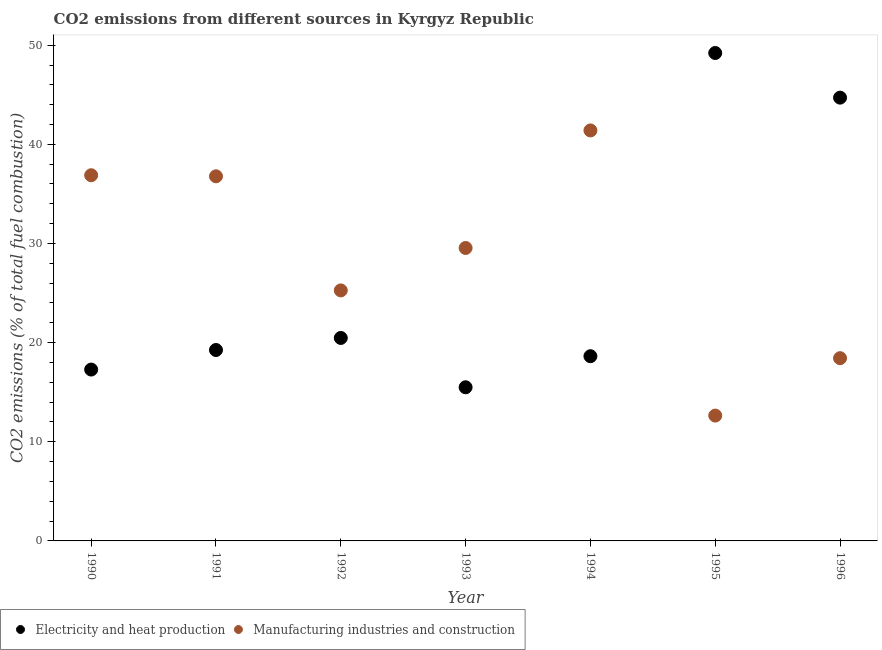Is the number of dotlines equal to the number of legend labels?
Give a very brief answer. Yes. What is the co2 emissions due to electricity and heat production in 1996?
Provide a short and direct response. 44.71. Across all years, what is the maximum co2 emissions due to electricity and heat production?
Make the answer very short. 49.21. Across all years, what is the minimum co2 emissions due to manufacturing industries?
Provide a short and direct response. 12.64. In which year was the co2 emissions due to manufacturing industries minimum?
Your answer should be compact. 1995. What is the total co2 emissions due to manufacturing industries in the graph?
Ensure brevity in your answer.  200.94. What is the difference between the co2 emissions due to electricity and heat production in 1992 and that in 1993?
Your answer should be very brief. 4.98. What is the difference between the co2 emissions due to manufacturing industries in 1994 and the co2 emissions due to electricity and heat production in 1993?
Ensure brevity in your answer.  25.91. What is the average co2 emissions due to electricity and heat production per year?
Your answer should be very brief. 26.44. In the year 1994, what is the difference between the co2 emissions due to electricity and heat production and co2 emissions due to manufacturing industries?
Your answer should be very brief. -22.77. What is the ratio of the co2 emissions due to manufacturing industries in 1992 to that in 1994?
Offer a very short reply. 0.61. Is the co2 emissions due to manufacturing industries in 1990 less than that in 1994?
Keep it short and to the point. Yes. What is the difference between the highest and the second highest co2 emissions due to manufacturing industries?
Provide a short and direct response. 4.52. What is the difference between the highest and the lowest co2 emissions due to electricity and heat production?
Your response must be concise. 33.71. Does the co2 emissions due to electricity and heat production monotonically increase over the years?
Offer a very short reply. No. Is the co2 emissions due to manufacturing industries strictly greater than the co2 emissions due to electricity and heat production over the years?
Your answer should be very brief. No. How many dotlines are there?
Provide a short and direct response. 2. What is the difference between two consecutive major ticks on the Y-axis?
Offer a terse response. 10. Are the values on the major ticks of Y-axis written in scientific E-notation?
Make the answer very short. No. Does the graph contain grids?
Offer a very short reply. No. How are the legend labels stacked?
Make the answer very short. Horizontal. What is the title of the graph?
Provide a short and direct response. CO2 emissions from different sources in Kyrgyz Republic. Does "Overweight" appear as one of the legend labels in the graph?
Make the answer very short. No. What is the label or title of the Y-axis?
Make the answer very short. CO2 emissions (% of total fuel combustion). What is the CO2 emissions (% of total fuel combustion) in Electricity and heat production in 1990?
Give a very brief answer. 17.28. What is the CO2 emissions (% of total fuel combustion) in Manufacturing industries and construction in 1990?
Provide a succinct answer. 36.88. What is the CO2 emissions (% of total fuel combustion) in Electricity and heat production in 1991?
Your answer should be compact. 19.26. What is the CO2 emissions (% of total fuel combustion) of Manufacturing industries and construction in 1991?
Give a very brief answer. 36.77. What is the CO2 emissions (% of total fuel combustion) of Electricity and heat production in 1992?
Your response must be concise. 20.47. What is the CO2 emissions (% of total fuel combustion) in Manufacturing industries and construction in 1992?
Offer a terse response. 25.27. What is the CO2 emissions (% of total fuel combustion) in Electricity and heat production in 1993?
Your response must be concise. 15.5. What is the CO2 emissions (% of total fuel combustion) of Manufacturing industries and construction in 1993?
Keep it short and to the point. 29.55. What is the CO2 emissions (% of total fuel combustion) in Electricity and heat production in 1994?
Your response must be concise. 18.63. What is the CO2 emissions (% of total fuel combustion) of Manufacturing industries and construction in 1994?
Make the answer very short. 41.4. What is the CO2 emissions (% of total fuel combustion) in Electricity and heat production in 1995?
Keep it short and to the point. 49.21. What is the CO2 emissions (% of total fuel combustion) of Manufacturing industries and construction in 1995?
Ensure brevity in your answer.  12.64. What is the CO2 emissions (% of total fuel combustion) of Electricity and heat production in 1996?
Ensure brevity in your answer.  44.71. What is the CO2 emissions (% of total fuel combustion) in Manufacturing industries and construction in 1996?
Provide a succinct answer. 18.43. Across all years, what is the maximum CO2 emissions (% of total fuel combustion) in Electricity and heat production?
Give a very brief answer. 49.21. Across all years, what is the maximum CO2 emissions (% of total fuel combustion) of Manufacturing industries and construction?
Your answer should be compact. 41.4. Across all years, what is the minimum CO2 emissions (% of total fuel combustion) of Electricity and heat production?
Offer a very short reply. 15.5. Across all years, what is the minimum CO2 emissions (% of total fuel combustion) in Manufacturing industries and construction?
Make the answer very short. 12.64. What is the total CO2 emissions (% of total fuel combustion) in Electricity and heat production in the graph?
Offer a terse response. 185.05. What is the total CO2 emissions (% of total fuel combustion) in Manufacturing industries and construction in the graph?
Your response must be concise. 200.94. What is the difference between the CO2 emissions (% of total fuel combustion) in Electricity and heat production in 1990 and that in 1991?
Ensure brevity in your answer.  -1.97. What is the difference between the CO2 emissions (% of total fuel combustion) of Manufacturing industries and construction in 1990 and that in 1991?
Your answer should be very brief. 0.11. What is the difference between the CO2 emissions (% of total fuel combustion) in Electricity and heat production in 1990 and that in 1992?
Offer a terse response. -3.19. What is the difference between the CO2 emissions (% of total fuel combustion) in Manufacturing industries and construction in 1990 and that in 1992?
Provide a short and direct response. 11.62. What is the difference between the CO2 emissions (% of total fuel combustion) in Electricity and heat production in 1990 and that in 1993?
Provide a short and direct response. 1.79. What is the difference between the CO2 emissions (% of total fuel combustion) of Manufacturing industries and construction in 1990 and that in 1993?
Offer a terse response. 7.34. What is the difference between the CO2 emissions (% of total fuel combustion) of Electricity and heat production in 1990 and that in 1994?
Give a very brief answer. -1.35. What is the difference between the CO2 emissions (% of total fuel combustion) in Manufacturing industries and construction in 1990 and that in 1994?
Keep it short and to the point. -4.52. What is the difference between the CO2 emissions (% of total fuel combustion) of Electricity and heat production in 1990 and that in 1995?
Ensure brevity in your answer.  -31.93. What is the difference between the CO2 emissions (% of total fuel combustion) in Manufacturing industries and construction in 1990 and that in 1995?
Your answer should be very brief. 24.24. What is the difference between the CO2 emissions (% of total fuel combustion) in Electricity and heat production in 1990 and that in 1996?
Give a very brief answer. -27.43. What is the difference between the CO2 emissions (% of total fuel combustion) in Manufacturing industries and construction in 1990 and that in 1996?
Your response must be concise. 18.45. What is the difference between the CO2 emissions (% of total fuel combustion) in Electricity and heat production in 1991 and that in 1992?
Keep it short and to the point. -1.22. What is the difference between the CO2 emissions (% of total fuel combustion) of Manufacturing industries and construction in 1991 and that in 1992?
Provide a succinct answer. 11.51. What is the difference between the CO2 emissions (% of total fuel combustion) in Electricity and heat production in 1991 and that in 1993?
Keep it short and to the point. 3.76. What is the difference between the CO2 emissions (% of total fuel combustion) of Manufacturing industries and construction in 1991 and that in 1993?
Your answer should be compact. 7.23. What is the difference between the CO2 emissions (% of total fuel combustion) of Manufacturing industries and construction in 1991 and that in 1994?
Give a very brief answer. -4.63. What is the difference between the CO2 emissions (% of total fuel combustion) in Electricity and heat production in 1991 and that in 1995?
Offer a very short reply. -29.95. What is the difference between the CO2 emissions (% of total fuel combustion) of Manufacturing industries and construction in 1991 and that in 1995?
Offer a very short reply. 24.13. What is the difference between the CO2 emissions (% of total fuel combustion) in Electricity and heat production in 1991 and that in 1996?
Offer a terse response. -25.45. What is the difference between the CO2 emissions (% of total fuel combustion) of Manufacturing industries and construction in 1991 and that in 1996?
Make the answer very short. 18.34. What is the difference between the CO2 emissions (% of total fuel combustion) of Electricity and heat production in 1992 and that in 1993?
Make the answer very short. 4.98. What is the difference between the CO2 emissions (% of total fuel combustion) of Manufacturing industries and construction in 1992 and that in 1993?
Offer a terse response. -4.28. What is the difference between the CO2 emissions (% of total fuel combustion) in Electricity and heat production in 1992 and that in 1994?
Offer a terse response. 1.84. What is the difference between the CO2 emissions (% of total fuel combustion) of Manufacturing industries and construction in 1992 and that in 1994?
Ensure brevity in your answer.  -16.13. What is the difference between the CO2 emissions (% of total fuel combustion) of Electricity and heat production in 1992 and that in 1995?
Ensure brevity in your answer.  -28.74. What is the difference between the CO2 emissions (% of total fuel combustion) of Manufacturing industries and construction in 1992 and that in 1995?
Provide a short and direct response. 12.63. What is the difference between the CO2 emissions (% of total fuel combustion) of Electricity and heat production in 1992 and that in 1996?
Give a very brief answer. -24.24. What is the difference between the CO2 emissions (% of total fuel combustion) of Manufacturing industries and construction in 1992 and that in 1996?
Provide a short and direct response. 6.84. What is the difference between the CO2 emissions (% of total fuel combustion) in Electricity and heat production in 1993 and that in 1994?
Keep it short and to the point. -3.13. What is the difference between the CO2 emissions (% of total fuel combustion) in Manufacturing industries and construction in 1993 and that in 1994?
Ensure brevity in your answer.  -11.86. What is the difference between the CO2 emissions (% of total fuel combustion) in Electricity and heat production in 1993 and that in 1995?
Your answer should be very brief. -33.71. What is the difference between the CO2 emissions (% of total fuel combustion) in Manufacturing industries and construction in 1993 and that in 1995?
Offer a terse response. 16.9. What is the difference between the CO2 emissions (% of total fuel combustion) of Electricity and heat production in 1993 and that in 1996?
Keep it short and to the point. -29.21. What is the difference between the CO2 emissions (% of total fuel combustion) of Manufacturing industries and construction in 1993 and that in 1996?
Make the answer very short. 11.11. What is the difference between the CO2 emissions (% of total fuel combustion) of Electricity and heat production in 1994 and that in 1995?
Your response must be concise. -30.58. What is the difference between the CO2 emissions (% of total fuel combustion) of Manufacturing industries and construction in 1994 and that in 1995?
Your answer should be compact. 28.76. What is the difference between the CO2 emissions (% of total fuel combustion) in Electricity and heat production in 1994 and that in 1996?
Offer a terse response. -26.08. What is the difference between the CO2 emissions (% of total fuel combustion) of Manufacturing industries and construction in 1994 and that in 1996?
Make the answer very short. 22.97. What is the difference between the CO2 emissions (% of total fuel combustion) of Electricity and heat production in 1995 and that in 1996?
Make the answer very short. 4.5. What is the difference between the CO2 emissions (% of total fuel combustion) in Manufacturing industries and construction in 1995 and that in 1996?
Provide a short and direct response. -5.79. What is the difference between the CO2 emissions (% of total fuel combustion) in Electricity and heat production in 1990 and the CO2 emissions (% of total fuel combustion) in Manufacturing industries and construction in 1991?
Ensure brevity in your answer.  -19.49. What is the difference between the CO2 emissions (% of total fuel combustion) in Electricity and heat production in 1990 and the CO2 emissions (% of total fuel combustion) in Manufacturing industries and construction in 1992?
Provide a short and direct response. -7.98. What is the difference between the CO2 emissions (% of total fuel combustion) in Electricity and heat production in 1990 and the CO2 emissions (% of total fuel combustion) in Manufacturing industries and construction in 1993?
Provide a succinct answer. -12.26. What is the difference between the CO2 emissions (% of total fuel combustion) of Electricity and heat production in 1990 and the CO2 emissions (% of total fuel combustion) of Manufacturing industries and construction in 1994?
Make the answer very short. -24.12. What is the difference between the CO2 emissions (% of total fuel combustion) in Electricity and heat production in 1990 and the CO2 emissions (% of total fuel combustion) in Manufacturing industries and construction in 1995?
Your response must be concise. 4.64. What is the difference between the CO2 emissions (% of total fuel combustion) of Electricity and heat production in 1990 and the CO2 emissions (% of total fuel combustion) of Manufacturing industries and construction in 1996?
Offer a terse response. -1.15. What is the difference between the CO2 emissions (% of total fuel combustion) of Electricity and heat production in 1991 and the CO2 emissions (% of total fuel combustion) of Manufacturing industries and construction in 1992?
Offer a terse response. -6.01. What is the difference between the CO2 emissions (% of total fuel combustion) of Electricity and heat production in 1991 and the CO2 emissions (% of total fuel combustion) of Manufacturing industries and construction in 1993?
Your response must be concise. -10.29. What is the difference between the CO2 emissions (% of total fuel combustion) of Electricity and heat production in 1991 and the CO2 emissions (% of total fuel combustion) of Manufacturing industries and construction in 1994?
Offer a very short reply. -22.15. What is the difference between the CO2 emissions (% of total fuel combustion) of Electricity and heat production in 1991 and the CO2 emissions (% of total fuel combustion) of Manufacturing industries and construction in 1995?
Offer a very short reply. 6.61. What is the difference between the CO2 emissions (% of total fuel combustion) of Electricity and heat production in 1991 and the CO2 emissions (% of total fuel combustion) of Manufacturing industries and construction in 1996?
Your response must be concise. 0.82. What is the difference between the CO2 emissions (% of total fuel combustion) of Electricity and heat production in 1992 and the CO2 emissions (% of total fuel combustion) of Manufacturing industries and construction in 1993?
Make the answer very short. -9.07. What is the difference between the CO2 emissions (% of total fuel combustion) of Electricity and heat production in 1992 and the CO2 emissions (% of total fuel combustion) of Manufacturing industries and construction in 1994?
Keep it short and to the point. -20.93. What is the difference between the CO2 emissions (% of total fuel combustion) in Electricity and heat production in 1992 and the CO2 emissions (% of total fuel combustion) in Manufacturing industries and construction in 1995?
Your response must be concise. 7.83. What is the difference between the CO2 emissions (% of total fuel combustion) of Electricity and heat production in 1992 and the CO2 emissions (% of total fuel combustion) of Manufacturing industries and construction in 1996?
Ensure brevity in your answer.  2.04. What is the difference between the CO2 emissions (% of total fuel combustion) in Electricity and heat production in 1993 and the CO2 emissions (% of total fuel combustion) in Manufacturing industries and construction in 1994?
Offer a terse response. -25.91. What is the difference between the CO2 emissions (% of total fuel combustion) in Electricity and heat production in 1993 and the CO2 emissions (% of total fuel combustion) in Manufacturing industries and construction in 1995?
Ensure brevity in your answer.  2.85. What is the difference between the CO2 emissions (% of total fuel combustion) in Electricity and heat production in 1993 and the CO2 emissions (% of total fuel combustion) in Manufacturing industries and construction in 1996?
Your answer should be compact. -2.93. What is the difference between the CO2 emissions (% of total fuel combustion) in Electricity and heat production in 1994 and the CO2 emissions (% of total fuel combustion) in Manufacturing industries and construction in 1995?
Keep it short and to the point. 5.99. What is the difference between the CO2 emissions (% of total fuel combustion) of Electricity and heat production in 1994 and the CO2 emissions (% of total fuel combustion) of Manufacturing industries and construction in 1996?
Ensure brevity in your answer.  0.2. What is the difference between the CO2 emissions (% of total fuel combustion) of Electricity and heat production in 1995 and the CO2 emissions (% of total fuel combustion) of Manufacturing industries and construction in 1996?
Ensure brevity in your answer.  30.78. What is the average CO2 emissions (% of total fuel combustion) of Electricity and heat production per year?
Your answer should be compact. 26.44. What is the average CO2 emissions (% of total fuel combustion) of Manufacturing industries and construction per year?
Provide a short and direct response. 28.71. In the year 1990, what is the difference between the CO2 emissions (% of total fuel combustion) of Electricity and heat production and CO2 emissions (% of total fuel combustion) of Manufacturing industries and construction?
Your response must be concise. -19.6. In the year 1991, what is the difference between the CO2 emissions (% of total fuel combustion) in Electricity and heat production and CO2 emissions (% of total fuel combustion) in Manufacturing industries and construction?
Keep it short and to the point. -17.52. In the year 1992, what is the difference between the CO2 emissions (% of total fuel combustion) in Electricity and heat production and CO2 emissions (% of total fuel combustion) in Manufacturing industries and construction?
Keep it short and to the point. -4.79. In the year 1993, what is the difference between the CO2 emissions (% of total fuel combustion) of Electricity and heat production and CO2 emissions (% of total fuel combustion) of Manufacturing industries and construction?
Keep it short and to the point. -14.05. In the year 1994, what is the difference between the CO2 emissions (% of total fuel combustion) of Electricity and heat production and CO2 emissions (% of total fuel combustion) of Manufacturing industries and construction?
Your answer should be very brief. -22.77. In the year 1995, what is the difference between the CO2 emissions (% of total fuel combustion) in Electricity and heat production and CO2 emissions (% of total fuel combustion) in Manufacturing industries and construction?
Offer a terse response. 36.57. In the year 1996, what is the difference between the CO2 emissions (% of total fuel combustion) of Electricity and heat production and CO2 emissions (% of total fuel combustion) of Manufacturing industries and construction?
Your response must be concise. 26.28. What is the ratio of the CO2 emissions (% of total fuel combustion) in Electricity and heat production in 1990 to that in 1991?
Provide a succinct answer. 0.9. What is the ratio of the CO2 emissions (% of total fuel combustion) in Manufacturing industries and construction in 1990 to that in 1991?
Make the answer very short. 1. What is the ratio of the CO2 emissions (% of total fuel combustion) of Electricity and heat production in 1990 to that in 1992?
Your answer should be very brief. 0.84. What is the ratio of the CO2 emissions (% of total fuel combustion) in Manufacturing industries and construction in 1990 to that in 1992?
Keep it short and to the point. 1.46. What is the ratio of the CO2 emissions (% of total fuel combustion) in Electricity and heat production in 1990 to that in 1993?
Your answer should be very brief. 1.12. What is the ratio of the CO2 emissions (% of total fuel combustion) in Manufacturing industries and construction in 1990 to that in 1993?
Offer a very short reply. 1.25. What is the ratio of the CO2 emissions (% of total fuel combustion) in Electricity and heat production in 1990 to that in 1994?
Provide a short and direct response. 0.93. What is the ratio of the CO2 emissions (% of total fuel combustion) of Manufacturing industries and construction in 1990 to that in 1994?
Give a very brief answer. 0.89. What is the ratio of the CO2 emissions (% of total fuel combustion) in Electricity and heat production in 1990 to that in 1995?
Provide a succinct answer. 0.35. What is the ratio of the CO2 emissions (% of total fuel combustion) of Manufacturing industries and construction in 1990 to that in 1995?
Your response must be concise. 2.92. What is the ratio of the CO2 emissions (% of total fuel combustion) of Electricity and heat production in 1990 to that in 1996?
Provide a succinct answer. 0.39. What is the ratio of the CO2 emissions (% of total fuel combustion) in Manufacturing industries and construction in 1990 to that in 1996?
Make the answer very short. 2. What is the ratio of the CO2 emissions (% of total fuel combustion) in Electricity and heat production in 1991 to that in 1992?
Keep it short and to the point. 0.94. What is the ratio of the CO2 emissions (% of total fuel combustion) of Manufacturing industries and construction in 1991 to that in 1992?
Offer a very short reply. 1.46. What is the ratio of the CO2 emissions (% of total fuel combustion) of Electricity and heat production in 1991 to that in 1993?
Provide a succinct answer. 1.24. What is the ratio of the CO2 emissions (% of total fuel combustion) of Manufacturing industries and construction in 1991 to that in 1993?
Provide a succinct answer. 1.24. What is the ratio of the CO2 emissions (% of total fuel combustion) in Electricity and heat production in 1991 to that in 1994?
Offer a very short reply. 1.03. What is the ratio of the CO2 emissions (% of total fuel combustion) in Manufacturing industries and construction in 1991 to that in 1994?
Ensure brevity in your answer.  0.89. What is the ratio of the CO2 emissions (% of total fuel combustion) of Electricity and heat production in 1991 to that in 1995?
Your answer should be compact. 0.39. What is the ratio of the CO2 emissions (% of total fuel combustion) of Manufacturing industries and construction in 1991 to that in 1995?
Make the answer very short. 2.91. What is the ratio of the CO2 emissions (% of total fuel combustion) in Electricity and heat production in 1991 to that in 1996?
Your answer should be very brief. 0.43. What is the ratio of the CO2 emissions (% of total fuel combustion) of Manufacturing industries and construction in 1991 to that in 1996?
Keep it short and to the point. 2. What is the ratio of the CO2 emissions (% of total fuel combustion) in Electricity and heat production in 1992 to that in 1993?
Give a very brief answer. 1.32. What is the ratio of the CO2 emissions (% of total fuel combustion) in Manufacturing industries and construction in 1992 to that in 1993?
Offer a very short reply. 0.86. What is the ratio of the CO2 emissions (% of total fuel combustion) of Electricity and heat production in 1992 to that in 1994?
Provide a short and direct response. 1.1. What is the ratio of the CO2 emissions (% of total fuel combustion) in Manufacturing industries and construction in 1992 to that in 1994?
Provide a short and direct response. 0.61. What is the ratio of the CO2 emissions (% of total fuel combustion) in Electricity and heat production in 1992 to that in 1995?
Give a very brief answer. 0.42. What is the ratio of the CO2 emissions (% of total fuel combustion) in Manufacturing industries and construction in 1992 to that in 1995?
Offer a very short reply. 2. What is the ratio of the CO2 emissions (% of total fuel combustion) in Electricity and heat production in 1992 to that in 1996?
Make the answer very short. 0.46. What is the ratio of the CO2 emissions (% of total fuel combustion) of Manufacturing industries and construction in 1992 to that in 1996?
Your response must be concise. 1.37. What is the ratio of the CO2 emissions (% of total fuel combustion) of Electricity and heat production in 1993 to that in 1994?
Provide a short and direct response. 0.83. What is the ratio of the CO2 emissions (% of total fuel combustion) in Manufacturing industries and construction in 1993 to that in 1994?
Offer a terse response. 0.71. What is the ratio of the CO2 emissions (% of total fuel combustion) in Electricity and heat production in 1993 to that in 1995?
Keep it short and to the point. 0.31. What is the ratio of the CO2 emissions (% of total fuel combustion) in Manufacturing industries and construction in 1993 to that in 1995?
Your response must be concise. 2.34. What is the ratio of the CO2 emissions (% of total fuel combustion) of Electricity and heat production in 1993 to that in 1996?
Make the answer very short. 0.35. What is the ratio of the CO2 emissions (% of total fuel combustion) of Manufacturing industries and construction in 1993 to that in 1996?
Make the answer very short. 1.6. What is the ratio of the CO2 emissions (% of total fuel combustion) of Electricity and heat production in 1994 to that in 1995?
Your answer should be compact. 0.38. What is the ratio of the CO2 emissions (% of total fuel combustion) of Manufacturing industries and construction in 1994 to that in 1995?
Your response must be concise. 3.28. What is the ratio of the CO2 emissions (% of total fuel combustion) in Electricity and heat production in 1994 to that in 1996?
Provide a succinct answer. 0.42. What is the ratio of the CO2 emissions (% of total fuel combustion) of Manufacturing industries and construction in 1994 to that in 1996?
Your answer should be very brief. 2.25. What is the ratio of the CO2 emissions (% of total fuel combustion) in Electricity and heat production in 1995 to that in 1996?
Your response must be concise. 1.1. What is the ratio of the CO2 emissions (% of total fuel combustion) of Manufacturing industries and construction in 1995 to that in 1996?
Make the answer very short. 0.69. What is the difference between the highest and the second highest CO2 emissions (% of total fuel combustion) in Electricity and heat production?
Give a very brief answer. 4.5. What is the difference between the highest and the second highest CO2 emissions (% of total fuel combustion) of Manufacturing industries and construction?
Keep it short and to the point. 4.52. What is the difference between the highest and the lowest CO2 emissions (% of total fuel combustion) in Electricity and heat production?
Provide a short and direct response. 33.71. What is the difference between the highest and the lowest CO2 emissions (% of total fuel combustion) in Manufacturing industries and construction?
Provide a succinct answer. 28.76. 